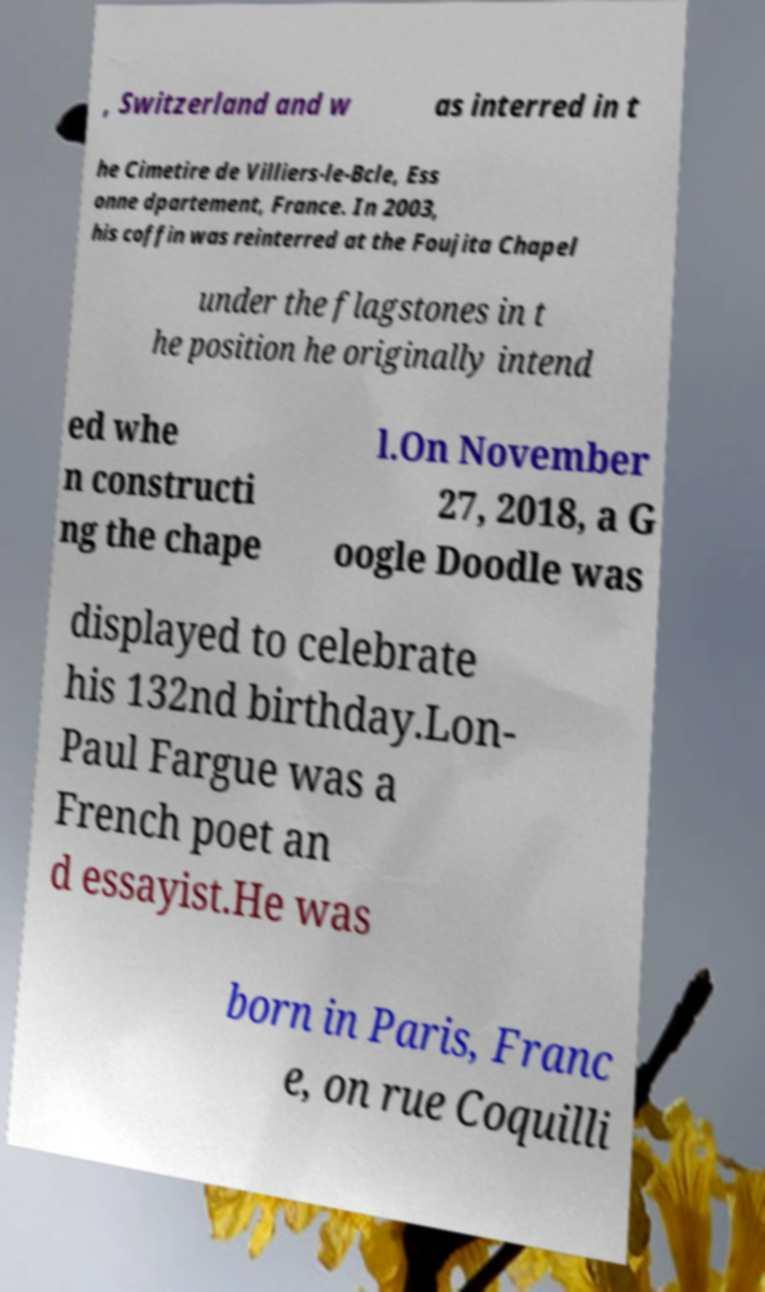For documentation purposes, I need the text within this image transcribed. Could you provide that? , Switzerland and w as interred in t he Cimetire de Villiers-le-Bcle, Ess onne dpartement, France. In 2003, his coffin was reinterred at the Foujita Chapel under the flagstones in t he position he originally intend ed whe n constructi ng the chape l.On November 27, 2018, a G oogle Doodle was displayed to celebrate his 132nd birthday.Lon- Paul Fargue was a French poet an d essayist.He was born in Paris, Franc e, on rue Coquilli 